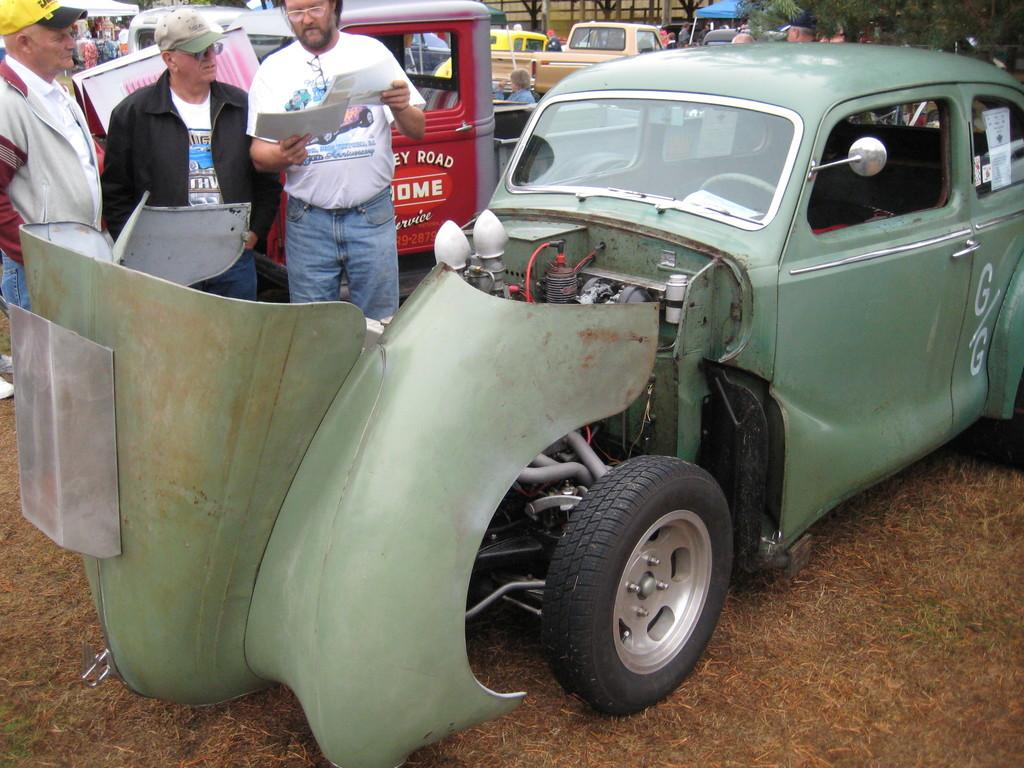What can be seen on the road in the image? There are vehicles parked on the road in the image. What are the people in the image doing? There are people standing beside the vehicles in the image. Can you describe the man in the image? A man is holding papers in his hand in the image. How many chickens are standing beside the vehicles in the image? There are no chickens present in the image; only people and vehicles can be seen. What type of garden can be seen in the image? There is no garden present in the image. 